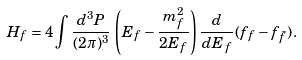<formula> <loc_0><loc_0><loc_500><loc_500>H _ { f } = 4 \int \frac { d ^ { 3 } P } { ( 2 \pi ) ^ { 3 } } \, \left ( E _ { f } - { \frac { m _ { f } ^ { 2 } } { 2 E _ { f } } } \right ) { \frac { d } { d E _ { f } } } ( f _ { f } - f _ { \bar { f } } ) \, .</formula> 